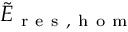<formula> <loc_0><loc_0><loc_500><loc_500>\tilde { E } _ { r e s , h o m }</formula> 